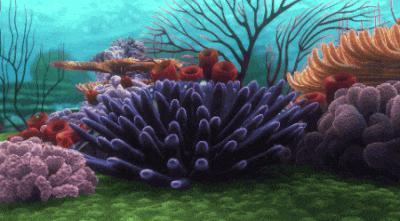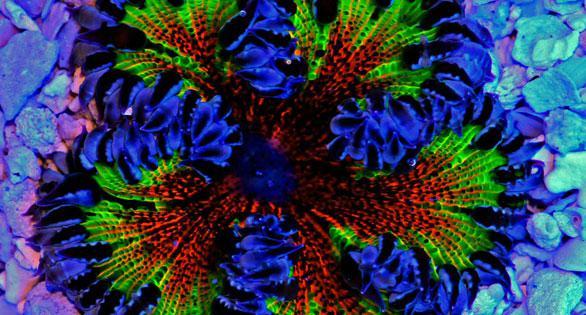The first image is the image on the left, the second image is the image on the right. For the images shown, is this caption "The anemones in the left image is pink." true? Answer yes or no. No. The first image is the image on the left, the second image is the image on the right. For the images shown, is this caption "The left image contains only pink anemone, and the right image includes an anemone with tendrils sprouting upward." true? Answer yes or no. No. 